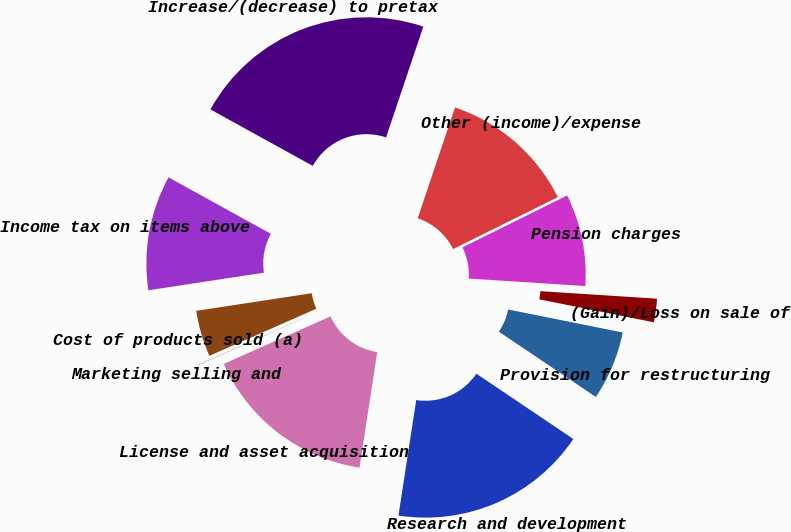<chart> <loc_0><loc_0><loc_500><loc_500><pie_chart><fcel>Cost of products sold (a)<fcel>Marketing selling and<fcel>License and asset acquisition<fcel>Research and development<fcel>Provision for restructuring<fcel>(Gain)/Loss on sale of<fcel>Pension charges<fcel>Other (income)/expense<fcel>Increase/(decrease) to pretax<fcel>Income tax on items above<nl><fcel>4.2%<fcel>0.05%<fcel>15.91%<fcel>17.99%<fcel>6.28%<fcel>2.13%<fcel>8.35%<fcel>12.5%<fcel>22.14%<fcel>10.43%<nl></chart> 